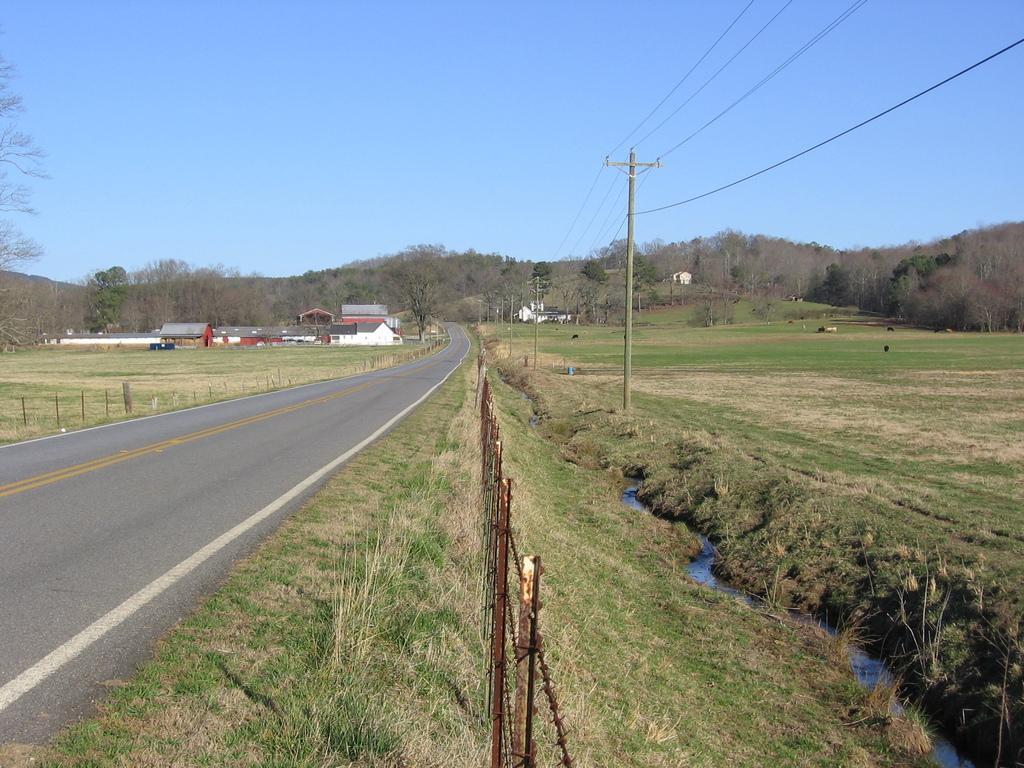How would you summarize this image in a sentence or two? In the foreground of this image, there is a fencing, grass land, road and the water. In the middle, there is a pole and cables. In the background, there are trees, poles, buildings and the sky. 